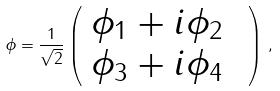<formula> <loc_0><loc_0><loc_500><loc_500>\phi = \frac { 1 } { \sqrt { 2 } } \left ( \begin{array} { l l } \phi _ { 1 } + i \phi _ { 2 } & \\ \phi _ { 3 } + i \phi _ { 4 } & \end{array} \right ) \, ,</formula> 